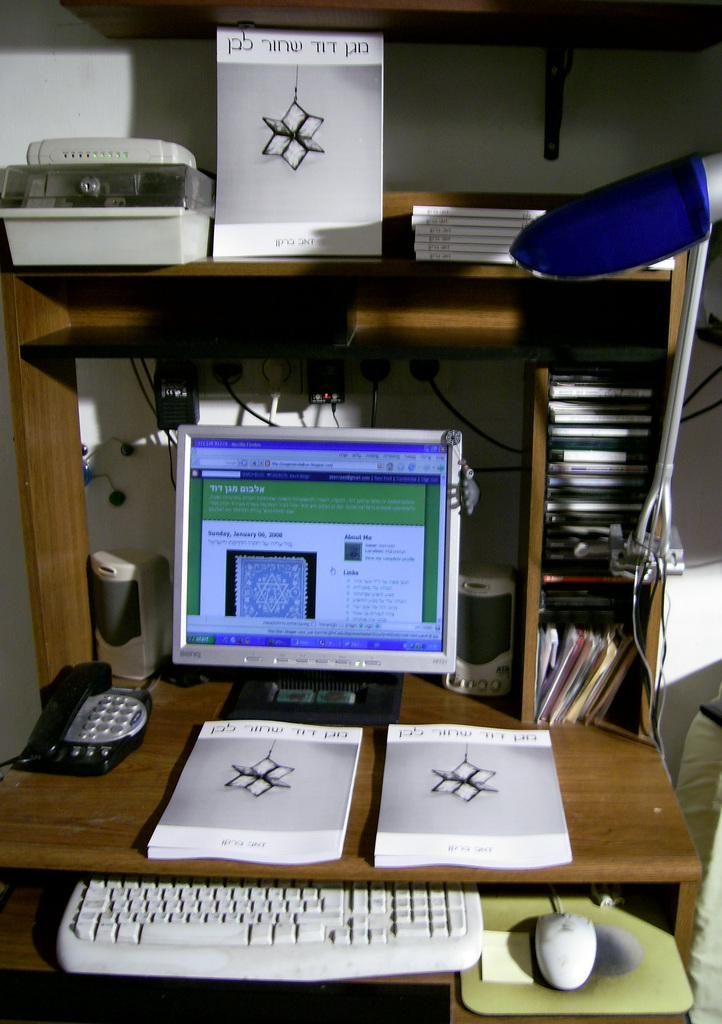What electronic device is visible in the image? There is a computer screen in the image. What input devices are present for the computer? There is a keyboard and a computer mouse in the image. What is used to provide a smooth surface for the mouse to move on? There is a mouse pad in the image. What type of items can be seen besides the computer equipment? There are books in the image. What is the color and material of the table where these items are placed? The table is brown and appears to be made of wood. What type of underwear is visible on the computer screen in the image? There is no underwear visible on the computer screen in the image. Is there a ring on the computer mouse in the image? There is no ring present on the computer mouse in the image. 